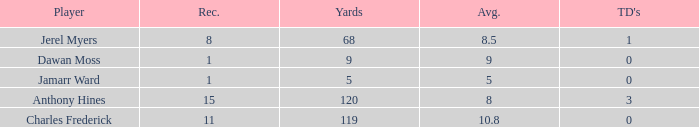Could you help me parse every detail presented in this table? {'header': ['Player', 'Rec.', 'Yards', 'Avg.', "TD's"], 'rows': [['Jerel Myers', '8', '68', '8.5', '1'], ['Dawan Moss', '1', '9', '9', '0'], ['Jamarr Ward', '1', '5', '5', '0'], ['Anthony Hines', '15', '120', '8', '3'], ['Charles Frederick', '11', '119', '10.8', '0']]} What is the highest number of TDs when the Avg is larger than 8.5 and the Rec is less than 1? None. 